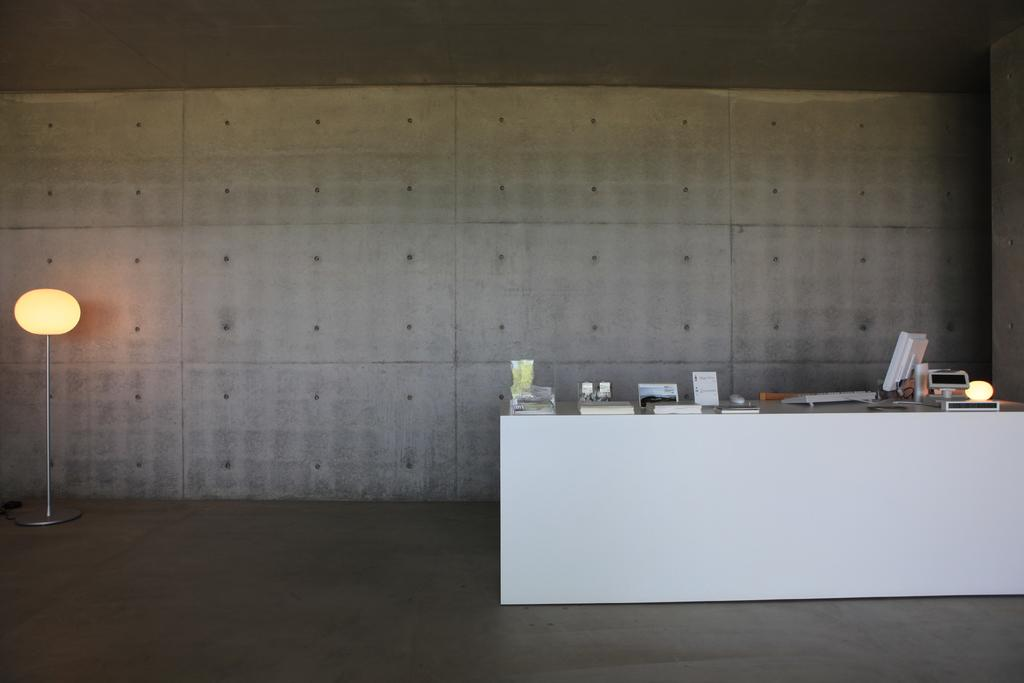What can be seen under the feet of the people or objects in the image? The ground is visible in the image. What piece of furniture is present in the image? There is a table in the image. What electronic device is on the table? There is a computer on the table. What type of items are on the table besides the computer? There are papers on the table. What is one of the architectural features in the image? There is a wall in the image. What can be seen providing illumination in the image? There are lights in the image. What vertical structure is present in the image? There is a pole in the image. What type of unit is being measured by the zinc in the image? There is no zinc present in the image, and therefore no unit measurement can be determined. What type of humor can be seen in the image? There is no humor depicted in the image; it is a scene with a table, computer, papers, wall, lights, and a pole. 